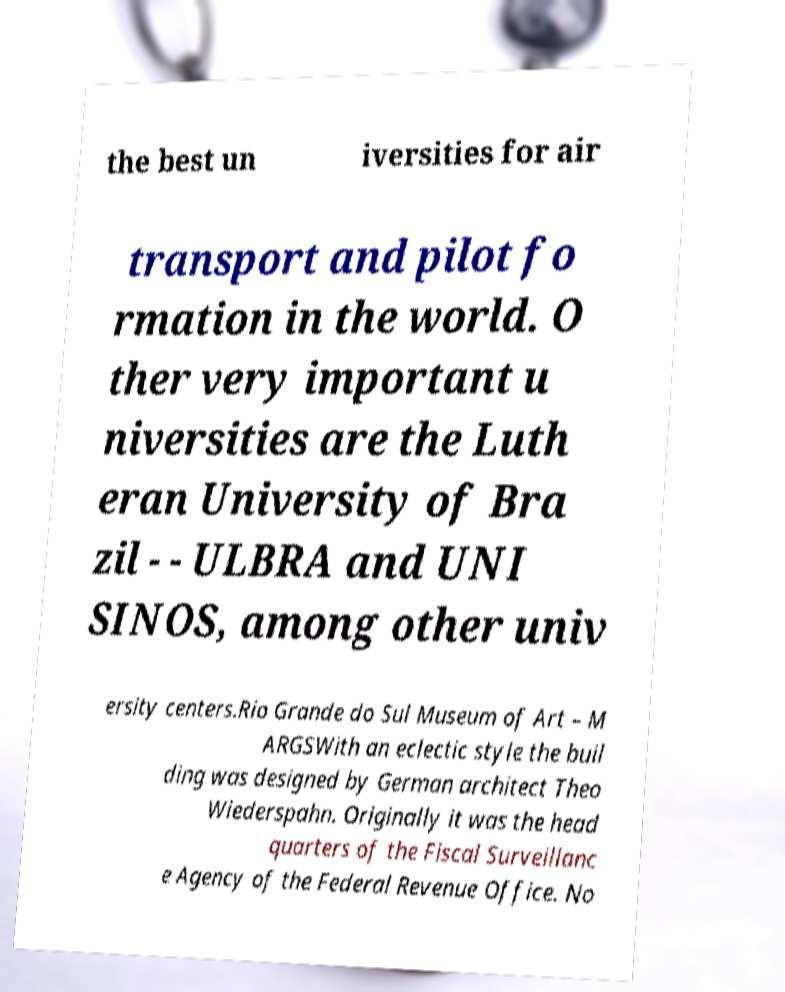Please identify and transcribe the text found in this image. the best un iversities for air transport and pilot fo rmation in the world. O ther very important u niversities are the Luth eran University of Bra zil - - ULBRA and UNI SINOS, among other univ ersity centers.Rio Grande do Sul Museum of Art – M ARGSWith an eclectic style the buil ding was designed by German architect Theo Wiederspahn. Originally it was the head quarters of the Fiscal Surveillanc e Agency of the Federal Revenue Office. No 